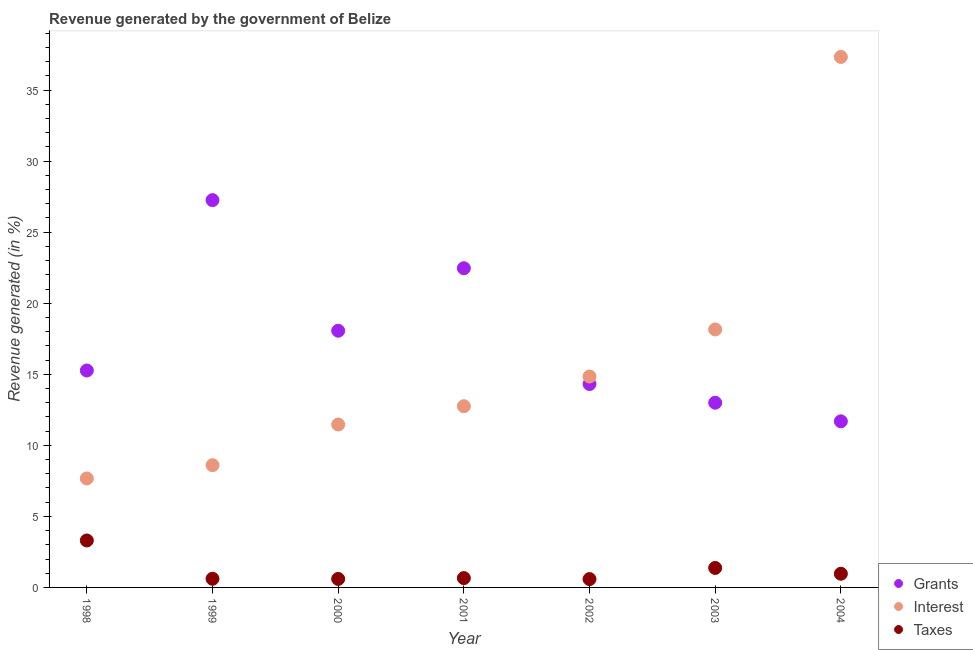What is the percentage of revenue generated by taxes in 2004?
Your answer should be very brief. 0.96. Across all years, what is the maximum percentage of revenue generated by grants?
Offer a terse response. 27.26. Across all years, what is the minimum percentage of revenue generated by grants?
Provide a succinct answer. 11.69. In which year was the percentage of revenue generated by grants minimum?
Ensure brevity in your answer.  2004. What is the total percentage of revenue generated by taxes in the graph?
Offer a very short reply. 8.09. What is the difference between the percentage of revenue generated by taxes in 1999 and that in 2001?
Provide a succinct answer. -0.05. What is the difference between the percentage of revenue generated by interest in 2000 and the percentage of revenue generated by grants in 2004?
Ensure brevity in your answer.  -0.22. What is the average percentage of revenue generated by interest per year?
Keep it short and to the point. 15.83. In the year 1998, what is the difference between the percentage of revenue generated by grants and percentage of revenue generated by interest?
Provide a short and direct response. 7.6. In how many years, is the percentage of revenue generated by taxes greater than 27 %?
Offer a very short reply. 0. What is the ratio of the percentage of revenue generated by interest in 1998 to that in 2003?
Offer a very short reply. 0.42. Is the percentage of revenue generated by grants in 1999 less than that in 2000?
Your answer should be very brief. No. Is the difference between the percentage of revenue generated by grants in 1998 and 2003 greater than the difference between the percentage of revenue generated by taxes in 1998 and 2003?
Keep it short and to the point. Yes. What is the difference between the highest and the second highest percentage of revenue generated by grants?
Ensure brevity in your answer.  4.79. What is the difference between the highest and the lowest percentage of revenue generated by taxes?
Keep it short and to the point. 2.72. Is the sum of the percentage of revenue generated by interest in 1998 and 2001 greater than the maximum percentage of revenue generated by taxes across all years?
Provide a succinct answer. Yes. Is it the case that in every year, the sum of the percentage of revenue generated by grants and percentage of revenue generated by interest is greater than the percentage of revenue generated by taxes?
Keep it short and to the point. Yes. Does the percentage of revenue generated by grants monotonically increase over the years?
Provide a succinct answer. No. Is the percentage of revenue generated by grants strictly less than the percentage of revenue generated by interest over the years?
Offer a very short reply. No. How many legend labels are there?
Provide a short and direct response. 3. What is the title of the graph?
Keep it short and to the point. Revenue generated by the government of Belize. What is the label or title of the X-axis?
Offer a very short reply. Year. What is the label or title of the Y-axis?
Make the answer very short. Revenue generated (in %). What is the Revenue generated (in %) of Grants in 1998?
Your answer should be very brief. 15.27. What is the Revenue generated (in %) of Interest in 1998?
Keep it short and to the point. 7.67. What is the Revenue generated (in %) of Taxes in 1998?
Your answer should be very brief. 3.3. What is the Revenue generated (in %) of Grants in 1999?
Ensure brevity in your answer.  27.26. What is the Revenue generated (in %) of Interest in 1999?
Your answer should be very brief. 8.6. What is the Revenue generated (in %) in Taxes in 1999?
Offer a very short reply. 0.61. What is the Revenue generated (in %) in Grants in 2000?
Provide a short and direct response. 18.07. What is the Revenue generated (in %) of Interest in 2000?
Provide a short and direct response. 11.47. What is the Revenue generated (in %) in Taxes in 2000?
Ensure brevity in your answer.  0.6. What is the Revenue generated (in %) of Grants in 2001?
Give a very brief answer. 22.46. What is the Revenue generated (in %) of Interest in 2001?
Provide a short and direct response. 12.75. What is the Revenue generated (in %) in Taxes in 2001?
Offer a very short reply. 0.66. What is the Revenue generated (in %) of Grants in 2002?
Offer a terse response. 14.31. What is the Revenue generated (in %) in Interest in 2002?
Give a very brief answer. 14.84. What is the Revenue generated (in %) in Taxes in 2002?
Your response must be concise. 0.59. What is the Revenue generated (in %) in Grants in 2003?
Provide a short and direct response. 13. What is the Revenue generated (in %) of Interest in 2003?
Make the answer very short. 18.15. What is the Revenue generated (in %) in Taxes in 2003?
Give a very brief answer. 1.37. What is the Revenue generated (in %) in Grants in 2004?
Provide a succinct answer. 11.69. What is the Revenue generated (in %) of Interest in 2004?
Make the answer very short. 37.33. What is the Revenue generated (in %) in Taxes in 2004?
Make the answer very short. 0.96. Across all years, what is the maximum Revenue generated (in %) of Grants?
Make the answer very short. 27.26. Across all years, what is the maximum Revenue generated (in %) of Interest?
Offer a very short reply. 37.33. Across all years, what is the maximum Revenue generated (in %) of Taxes?
Your answer should be compact. 3.3. Across all years, what is the minimum Revenue generated (in %) in Grants?
Your response must be concise. 11.69. Across all years, what is the minimum Revenue generated (in %) in Interest?
Provide a short and direct response. 7.67. Across all years, what is the minimum Revenue generated (in %) of Taxes?
Offer a very short reply. 0.59. What is the total Revenue generated (in %) of Grants in the graph?
Your response must be concise. 122.05. What is the total Revenue generated (in %) in Interest in the graph?
Provide a succinct answer. 110.82. What is the total Revenue generated (in %) of Taxes in the graph?
Offer a very short reply. 8.09. What is the difference between the Revenue generated (in %) of Grants in 1998 and that in 1999?
Ensure brevity in your answer.  -11.99. What is the difference between the Revenue generated (in %) in Interest in 1998 and that in 1999?
Make the answer very short. -0.94. What is the difference between the Revenue generated (in %) of Taxes in 1998 and that in 1999?
Your answer should be compact. 2.69. What is the difference between the Revenue generated (in %) in Grants in 1998 and that in 2000?
Your answer should be compact. -2.8. What is the difference between the Revenue generated (in %) of Interest in 1998 and that in 2000?
Make the answer very short. -3.8. What is the difference between the Revenue generated (in %) in Taxes in 1998 and that in 2000?
Ensure brevity in your answer.  2.71. What is the difference between the Revenue generated (in %) of Grants in 1998 and that in 2001?
Offer a terse response. -7.2. What is the difference between the Revenue generated (in %) in Interest in 1998 and that in 2001?
Give a very brief answer. -5.08. What is the difference between the Revenue generated (in %) in Taxes in 1998 and that in 2001?
Your answer should be compact. 2.65. What is the difference between the Revenue generated (in %) in Grants in 1998 and that in 2002?
Give a very brief answer. 0.95. What is the difference between the Revenue generated (in %) of Interest in 1998 and that in 2002?
Provide a succinct answer. -7.17. What is the difference between the Revenue generated (in %) in Taxes in 1998 and that in 2002?
Give a very brief answer. 2.72. What is the difference between the Revenue generated (in %) of Grants in 1998 and that in 2003?
Provide a short and direct response. 2.27. What is the difference between the Revenue generated (in %) of Interest in 1998 and that in 2003?
Give a very brief answer. -10.49. What is the difference between the Revenue generated (in %) in Taxes in 1998 and that in 2003?
Provide a short and direct response. 1.93. What is the difference between the Revenue generated (in %) of Grants in 1998 and that in 2004?
Ensure brevity in your answer.  3.58. What is the difference between the Revenue generated (in %) of Interest in 1998 and that in 2004?
Ensure brevity in your answer.  -29.66. What is the difference between the Revenue generated (in %) in Taxes in 1998 and that in 2004?
Give a very brief answer. 2.34. What is the difference between the Revenue generated (in %) of Grants in 1999 and that in 2000?
Provide a short and direct response. 9.19. What is the difference between the Revenue generated (in %) of Interest in 1999 and that in 2000?
Provide a short and direct response. -2.86. What is the difference between the Revenue generated (in %) of Taxes in 1999 and that in 2000?
Your answer should be compact. 0.01. What is the difference between the Revenue generated (in %) in Grants in 1999 and that in 2001?
Provide a short and direct response. 4.79. What is the difference between the Revenue generated (in %) of Interest in 1999 and that in 2001?
Offer a very short reply. -4.15. What is the difference between the Revenue generated (in %) in Taxes in 1999 and that in 2001?
Ensure brevity in your answer.  -0.05. What is the difference between the Revenue generated (in %) in Grants in 1999 and that in 2002?
Give a very brief answer. 12.94. What is the difference between the Revenue generated (in %) of Interest in 1999 and that in 2002?
Your answer should be very brief. -6.24. What is the difference between the Revenue generated (in %) in Taxes in 1999 and that in 2002?
Provide a succinct answer. 0.02. What is the difference between the Revenue generated (in %) in Grants in 1999 and that in 2003?
Your answer should be very brief. 14.26. What is the difference between the Revenue generated (in %) in Interest in 1999 and that in 2003?
Your answer should be compact. -9.55. What is the difference between the Revenue generated (in %) in Taxes in 1999 and that in 2003?
Your answer should be very brief. -0.76. What is the difference between the Revenue generated (in %) of Grants in 1999 and that in 2004?
Provide a succinct answer. 15.57. What is the difference between the Revenue generated (in %) of Interest in 1999 and that in 2004?
Provide a succinct answer. -28.73. What is the difference between the Revenue generated (in %) of Taxes in 1999 and that in 2004?
Offer a terse response. -0.35. What is the difference between the Revenue generated (in %) in Grants in 2000 and that in 2001?
Your answer should be compact. -4.4. What is the difference between the Revenue generated (in %) of Interest in 2000 and that in 2001?
Give a very brief answer. -1.29. What is the difference between the Revenue generated (in %) of Taxes in 2000 and that in 2001?
Ensure brevity in your answer.  -0.06. What is the difference between the Revenue generated (in %) of Grants in 2000 and that in 2002?
Keep it short and to the point. 3.75. What is the difference between the Revenue generated (in %) in Interest in 2000 and that in 2002?
Your response must be concise. -3.38. What is the difference between the Revenue generated (in %) of Taxes in 2000 and that in 2002?
Give a very brief answer. 0.01. What is the difference between the Revenue generated (in %) of Grants in 2000 and that in 2003?
Your answer should be compact. 5.07. What is the difference between the Revenue generated (in %) in Interest in 2000 and that in 2003?
Keep it short and to the point. -6.69. What is the difference between the Revenue generated (in %) of Taxes in 2000 and that in 2003?
Offer a very short reply. -0.77. What is the difference between the Revenue generated (in %) of Grants in 2000 and that in 2004?
Give a very brief answer. 6.38. What is the difference between the Revenue generated (in %) of Interest in 2000 and that in 2004?
Your answer should be very brief. -25.87. What is the difference between the Revenue generated (in %) of Taxes in 2000 and that in 2004?
Give a very brief answer. -0.37. What is the difference between the Revenue generated (in %) in Grants in 2001 and that in 2002?
Give a very brief answer. 8.15. What is the difference between the Revenue generated (in %) in Interest in 2001 and that in 2002?
Give a very brief answer. -2.09. What is the difference between the Revenue generated (in %) in Taxes in 2001 and that in 2002?
Your answer should be very brief. 0.07. What is the difference between the Revenue generated (in %) in Grants in 2001 and that in 2003?
Offer a terse response. 9.46. What is the difference between the Revenue generated (in %) of Interest in 2001 and that in 2003?
Your response must be concise. -5.4. What is the difference between the Revenue generated (in %) of Taxes in 2001 and that in 2003?
Provide a succinct answer. -0.71. What is the difference between the Revenue generated (in %) in Grants in 2001 and that in 2004?
Ensure brevity in your answer.  10.77. What is the difference between the Revenue generated (in %) in Interest in 2001 and that in 2004?
Your response must be concise. -24.58. What is the difference between the Revenue generated (in %) of Taxes in 2001 and that in 2004?
Make the answer very short. -0.31. What is the difference between the Revenue generated (in %) of Grants in 2002 and that in 2003?
Offer a terse response. 1.32. What is the difference between the Revenue generated (in %) of Interest in 2002 and that in 2003?
Make the answer very short. -3.31. What is the difference between the Revenue generated (in %) in Taxes in 2002 and that in 2003?
Your answer should be compact. -0.78. What is the difference between the Revenue generated (in %) of Grants in 2002 and that in 2004?
Your response must be concise. 2.62. What is the difference between the Revenue generated (in %) in Interest in 2002 and that in 2004?
Provide a succinct answer. -22.49. What is the difference between the Revenue generated (in %) in Taxes in 2002 and that in 2004?
Offer a very short reply. -0.38. What is the difference between the Revenue generated (in %) in Grants in 2003 and that in 2004?
Your response must be concise. 1.31. What is the difference between the Revenue generated (in %) of Interest in 2003 and that in 2004?
Keep it short and to the point. -19.18. What is the difference between the Revenue generated (in %) of Taxes in 2003 and that in 2004?
Provide a short and direct response. 0.41. What is the difference between the Revenue generated (in %) in Grants in 1998 and the Revenue generated (in %) in Interest in 1999?
Your response must be concise. 6.66. What is the difference between the Revenue generated (in %) in Grants in 1998 and the Revenue generated (in %) in Taxes in 1999?
Offer a terse response. 14.66. What is the difference between the Revenue generated (in %) of Interest in 1998 and the Revenue generated (in %) of Taxes in 1999?
Make the answer very short. 7.06. What is the difference between the Revenue generated (in %) in Grants in 1998 and the Revenue generated (in %) in Interest in 2000?
Offer a terse response. 3.8. What is the difference between the Revenue generated (in %) of Grants in 1998 and the Revenue generated (in %) of Taxes in 2000?
Ensure brevity in your answer.  14.67. What is the difference between the Revenue generated (in %) of Interest in 1998 and the Revenue generated (in %) of Taxes in 2000?
Give a very brief answer. 7.07. What is the difference between the Revenue generated (in %) of Grants in 1998 and the Revenue generated (in %) of Interest in 2001?
Give a very brief answer. 2.51. What is the difference between the Revenue generated (in %) in Grants in 1998 and the Revenue generated (in %) in Taxes in 2001?
Provide a succinct answer. 14.61. What is the difference between the Revenue generated (in %) in Interest in 1998 and the Revenue generated (in %) in Taxes in 2001?
Make the answer very short. 7.01. What is the difference between the Revenue generated (in %) in Grants in 1998 and the Revenue generated (in %) in Interest in 2002?
Keep it short and to the point. 0.42. What is the difference between the Revenue generated (in %) of Grants in 1998 and the Revenue generated (in %) of Taxes in 2002?
Keep it short and to the point. 14.68. What is the difference between the Revenue generated (in %) in Interest in 1998 and the Revenue generated (in %) in Taxes in 2002?
Ensure brevity in your answer.  7.08. What is the difference between the Revenue generated (in %) of Grants in 1998 and the Revenue generated (in %) of Interest in 2003?
Your answer should be very brief. -2.89. What is the difference between the Revenue generated (in %) of Grants in 1998 and the Revenue generated (in %) of Taxes in 2003?
Offer a very short reply. 13.9. What is the difference between the Revenue generated (in %) of Interest in 1998 and the Revenue generated (in %) of Taxes in 2003?
Your answer should be very brief. 6.3. What is the difference between the Revenue generated (in %) of Grants in 1998 and the Revenue generated (in %) of Interest in 2004?
Provide a succinct answer. -22.07. What is the difference between the Revenue generated (in %) of Grants in 1998 and the Revenue generated (in %) of Taxes in 2004?
Your answer should be very brief. 14.3. What is the difference between the Revenue generated (in %) of Interest in 1998 and the Revenue generated (in %) of Taxes in 2004?
Provide a succinct answer. 6.7. What is the difference between the Revenue generated (in %) of Grants in 1999 and the Revenue generated (in %) of Interest in 2000?
Your response must be concise. 15.79. What is the difference between the Revenue generated (in %) of Grants in 1999 and the Revenue generated (in %) of Taxes in 2000?
Offer a very short reply. 26.66. What is the difference between the Revenue generated (in %) in Interest in 1999 and the Revenue generated (in %) in Taxes in 2000?
Your response must be concise. 8.01. What is the difference between the Revenue generated (in %) in Grants in 1999 and the Revenue generated (in %) in Interest in 2001?
Make the answer very short. 14.5. What is the difference between the Revenue generated (in %) in Grants in 1999 and the Revenue generated (in %) in Taxes in 2001?
Your answer should be very brief. 26.6. What is the difference between the Revenue generated (in %) in Interest in 1999 and the Revenue generated (in %) in Taxes in 2001?
Keep it short and to the point. 7.95. What is the difference between the Revenue generated (in %) of Grants in 1999 and the Revenue generated (in %) of Interest in 2002?
Offer a very short reply. 12.41. What is the difference between the Revenue generated (in %) in Grants in 1999 and the Revenue generated (in %) in Taxes in 2002?
Your response must be concise. 26.67. What is the difference between the Revenue generated (in %) of Interest in 1999 and the Revenue generated (in %) of Taxes in 2002?
Provide a succinct answer. 8.02. What is the difference between the Revenue generated (in %) in Grants in 1999 and the Revenue generated (in %) in Interest in 2003?
Provide a short and direct response. 9.1. What is the difference between the Revenue generated (in %) in Grants in 1999 and the Revenue generated (in %) in Taxes in 2003?
Your answer should be very brief. 25.88. What is the difference between the Revenue generated (in %) of Interest in 1999 and the Revenue generated (in %) of Taxes in 2003?
Provide a succinct answer. 7.23. What is the difference between the Revenue generated (in %) of Grants in 1999 and the Revenue generated (in %) of Interest in 2004?
Your answer should be compact. -10.08. What is the difference between the Revenue generated (in %) in Grants in 1999 and the Revenue generated (in %) in Taxes in 2004?
Offer a terse response. 26.29. What is the difference between the Revenue generated (in %) of Interest in 1999 and the Revenue generated (in %) of Taxes in 2004?
Keep it short and to the point. 7.64. What is the difference between the Revenue generated (in %) of Grants in 2000 and the Revenue generated (in %) of Interest in 2001?
Make the answer very short. 5.31. What is the difference between the Revenue generated (in %) of Grants in 2000 and the Revenue generated (in %) of Taxes in 2001?
Your answer should be compact. 17.41. What is the difference between the Revenue generated (in %) in Interest in 2000 and the Revenue generated (in %) in Taxes in 2001?
Your response must be concise. 10.81. What is the difference between the Revenue generated (in %) in Grants in 2000 and the Revenue generated (in %) in Interest in 2002?
Offer a very short reply. 3.22. What is the difference between the Revenue generated (in %) in Grants in 2000 and the Revenue generated (in %) in Taxes in 2002?
Offer a very short reply. 17.48. What is the difference between the Revenue generated (in %) in Interest in 2000 and the Revenue generated (in %) in Taxes in 2002?
Offer a very short reply. 10.88. What is the difference between the Revenue generated (in %) in Grants in 2000 and the Revenue generated (in %) in Interest in 2003?
Offer a terse response. -0.09. What is the difference between the Revenue generated (in %) in Grants in 2000 and the Revenue generated (in %) in Taxes in 2003?
Keep it short and to the point. 16.69. What is the difference between the Revenue generated (in %) in Interest in 2000 and the Revenue generated (in %) in Taxes in 2003?
Give a very brief answer. 10.09. What is the difference between the Revenue generated (in %) of Grants in 2000 and the Revenue generated (in %) of Interest in 2004?
Provide a succinct answer. -19.27. What is the difference between the Revenue generated (in %) in Grants in 2000 and the Revenue generated (in %) in Taxes in 2004?
Provide a succinct answer. 17.1. What is the difference between the Revenue generated (in %) of Interest in 2000 and the Revenue generated (in %) of Taxes in 2004?
Provide a succinct answer. 10.5. What is the difference between the Revenue generated (in %) of Grants in 2001 and the Revenue generated (in %) of Interest in 2002?
Keep it short and to the point. 7.62. What is the difference between the Revenue generated (in %) of Grants in 2001 and the Revenue generated (in %) of Taxes in 2002?
Provide a succinct answer. 21.88. What is the difference between the Revenue generated (in %) of Interest in 2001 and the Revenue generated (in %) of Taxes in 2002?
Ensure brevity in your answer.  12.16. What is the difference between the Revenue generated (in %) of Grants in 2001 and the Revenue generated (in %) of Interest in 2003?
Make the answer very short. 4.31. What is the difference between the Revenue generated (in %) in Grants in 2001 and the Revenue generated (in %) in Taxes in 2003?
Offer a very short reply. 21.09. What is the difference between the Revenue generated (in %) of Interest in 2001 and the Revenue generated (in %) of Taxes in 2003?
Provide a short and direct response. 11.38. What is the difference between the Revenue generated (in %) in Grants in 2001 and the Revenue generated (in %) in Interest in 2004?
Provide a short and direct response. -14.87. What is the difference between the Revenue generated (in %) of Grants in 2001 and the Revenue generated (in %) of Taxes in 2004?
Ensure brevity in your answer.  21.5. What is the difference between the Revenue generated (in %) in Interest in 2001 and the Revenue generated (in %) in Taxes in 2004?
Give a very brief answer. 11.79. What is the difference between the Revenue generated (in %) of Grants in 2002 and the Revenue generated (in %) of Interest in 2003?
Your answer should be compact. -3.84. What is the difference between the Revenue generated (in %) of Grants in 2002 and the Revenue generated (in %) of Taxes in 2003?
Your answer should be very brief. 12.94. What is the difference between the Revenue generated (in %) of Interest in 2002 and the Revenue generated (in %) of Taxes in 2003?
Keep it short and to the point. 13.47. What is the difference between the Revenue generated (in %) in Grants in 2002 and the Revenue generated (in %) in Interest in 2004?
Provide a succinct answer. -23.02. What is the difference between the Revenue generated (in %) of Grants in 2002 and the Revenue generated (in %) of Taxes in 2004?
Your answer should be very brief. 13.35. What is the difference between the Revenue generated (in %) of Interest in 2002 and the Revenue generated (in %) of Taxes in 2004?
Keep it short and to the point. 13.88. What is the difference between the Revenue generated (in %) in Grants in 2003 and the Revenue generated (in %) in Interest in 2004?
Provide a succinct answer. -24.33. What is the difference between the Revenue generated (in %) of Grants in 2003 and the Revenue generated (in %) of Taxes in 2004?
Provide a succinct answer. 12.04. What is the difference between the Revenue generated (in %) in Interest in 2003 and the Revenue generated (in %) in Taxes in 2004?
Make the answer very short. 17.19. What is the average Revenue generated (in %) in Grants per year?
Your answer should be very brief. 17.44. What is the average Revenue generated (in %) of Interest per year?
Offer a very short reply. 15.83. What is the average Revenue generated (in %) of Taxes per year?
Give a very brief answer. 1.16. In the year 1998, what is the difference between the Revenue generated (in %) of Grants and Revenue generated (in %) of Interest?
Offer a terse response. 7.6. In the year 1998, what is the difference between the Revenue generated (in %) in Grants and Revenue generated (in %) in Taxes?
Your response must be concise. 11.96. In the year 1998, what is the difference between the Revenue generated (in %) of Interest and Revenue generated (in %) of Taxes?
Your response must be concise. 4.36. In the year 1999, what is the difference between the Revenue generated (in %) in Grants and Revenue generated (in %) in Interest?
Your response must be concise. 18.65. In the year 1999, what is the difference between the Revenue generated (in %) in Grants and Revenue generated (in %) in Taxes?
Your response must be concise. 26.65. In the year 1999, what is the difference between the Revenue generated (in %) of Interest and Revenue generated (in %) of Taxes?
Make the answer very short. 7.99. In the year 2000, what is the difference between the Revenue generated (in %) in Grants and Revenue generated (in %) in Interest?
Provide a succinct answer. 6.6. In the year 2000, what is the difference between the Revenue generated (in %) of Grants and Revenue generated (in %) of Taxes?
Provide a succinct answer. 17.47. In the year 2000, what is the difference between the Revenue generated (in %) in Interest and Revenue generated (in %) in Taxes?
Provide a succinct answer. 10.87. In the year 2001, what is the difference between the Revenue generated (in %) in Grants and Revenue generated (in %) in Interest?
Ensure brevity in your answer.  9.71. In the year 2001, what is the difference between the Revenue generated (in %) in Grants and Revenue generated (in %) in Taxes?
Your answer should be very brief. 21.81. In the year 2001, what is the difference between the Revenue generated (in %) of Interest and Revenue generated (in %) of Taxes?
Give a very brief answer. 12.1. In the year 2002, what is the difference between the Revenue generated (in %) in Grants and Revenue generated (in %) in Interest?
Offer a very short reply. -0.53. In the year 2002, what is the difference between the Revenue generated (in %) in Grants and Revenue generated (in %) in Taxes?
Ensure brevity in your answer.  13.73. In the year 2002, what is the difference between the Revenue generated (in %) of Interest and Revenue generated (in %) of Taxes?
Offer a very short reply. 14.25. In the year 2003, what is the difference between the Revenue generated (in %) of Grants and Revenue generated (in %) of Interest?
Provide a succinct answer. -5.16. In the year 2003, what is the difference between the Revenue generated (in %) of Grants and Revenue generated (in %) of Taxes?
Your answer should be very brief. 11.63. In the year 2003, what is the difference between the Revenue generated (in %) of Interest and Revenue generated (in %) of Taxes?
Give a very brief answer. 16.78. In the year 2004, what is the difference between the Revenue generated (in %) in Grants and Revenue generated (in %) in Interest?
Your response must be concise. -25.64. In the year 2004, what is the difference between the Revenue generated (in %) of Grants and Revenue generated (in %) of Taxes?
Give a very brief answer. 10.73. In the year 2004, what is the difference between the Revenue generated (in %) in Interest and Revenue generated (in %) in Taxes?
Ensure brevity in your answer.  36.37. What is the ratio of the Revenue generated (in %) in Grants in 1998 to that in 1999?
Ensure brevity in your answer.  0.56. What is the ratio of the Revenue generated (in %) in Interest in 1998 to that in 1999?
Provide a succinct answer. 0.89. What is the ratio of the Revenue generated (in %) in Taxes in 1998 to that in 1999?
Provide a short and direct response. 5.42. What is the ratio of the Revenue generated (in %) in Grants in 1998 to that in 2000?
Ensure brevity in your answer.  0.85. What is the ratio of the Revenue generated (in %) of Interest in 1998 to that in 2000?
Keep it short and to the point. 0.67. What is the ratio of the Revenue generated (in %) in Taxes in 1998 to that in 2000?
Provide a succinct answer. 5.53. What is the ratio of the Revenue generated (in %) in Grants in 1998 to that in 2001?
Provide a short and direct response. 0.68. What is the ratio of the Revenue generated (in %) in Interest in 1998 to that in 2001?
Keep it short and to the point. 0.6. What is the ratio of the Revenue generated (in %) of Taxes in 1998 to that in 2001?
Ensure brevity in your answer.  5.03. What is the ratio of the Revenue generated (in %) in Grants in 1998 to that in 2002?
Offer a very short reply. 1.07. What is the ratio of the Revenue generated (in %) in Interest in 1998 to that in 2002?
Offer a terse response. 0.52. What is the ratio of the Revenue generated (in %) in Taxes in 1998 to that in 2002?
Provide a short and direct response. 5.62. What is the ratio of the Revenue generated (in %) of Grants in 1998 to that in 2003?
Provide a short and direct response. 1.17. What is the ratio of the Revenue generated (in %) in Interest in 1998 to that in 2003?
Your response must be concise. 0.42. What is the ratio of the Revenue generated (in %) in Taxes in 1998 to that in 2003?
Offer a very short reply. 2.41. What is the ratio of the Revenue generated (in %) of Grants in 1998 to that in 2004?
Your response must be concise. 1.31. What is the ratio of the Revenue generated (in %) of Interest in 1998 to that in 2004?
Ensure brevity in your answer.  0.21. What is the ratio of the Revenue generated (in %) in Taxes in 1998 to that in 2004?
Ensure brevity in your answer.  3.43. What is the ratio of the Revenue generated (in %) in Grants in 1999 to that in 2000?
Your answer should be compact. 1.51. What is the ratio of the Revenue generated (in %) of Interest in 1999 to that in 2000?
Keep it short and to the point. 0.75. What is the ratio of the Revenue generated (in %) in Taxes in 1999 to that in 2000?
Your answer should be very brief. 1.02. What is the ratio of the Revenue generated (in %) in Grants in 1999 to that in 2001?
Make the answer very short. 1.21. What is the ratio of the Revenue generated (in %) of Interest in 1999 to that in 2001?
Offer a terse response. 0.67. What is the ratio of the Revenue generated (in %) of Taxes in 1999 to that in 2001?
Make the answer very short. 0.93. What is the ratio of the Revenue generated (in %) in Grants in 1999 to that in 2002?
Your answer should be very brief. 1.9. What is the ratio of the Revenue generated (in %) in Interest in 1999 to that in 2002?
Offer a terse response. 0.58. What is the ratio of the Revenue generated (in %) of Taxes in 1999 to that in 2002?
Provide a short and direct response. 1.04. What is the ratio of the Revenue generated (in %) in Grants in 1999 to that in 2003?
Offer a terse response. 2.1. What is the ratio of the Revenue generated (in %) of Interest in 1999 to that in 2003?
Give a very brief answer. 0.47. What is the ratio of the Revenue generated (in %) in Taxes in 1999 to that in 2003?
Offer a very short reply. 0.44. What is the ratio of the Revenue generated (in %) in Grants in 1999 to that in 2004?
Offer a very short reply. 2.33. What is the ratio of the Revenue generated (in %) in Interest in 1999 to that in 2004?
Provide a succinct answer. 0.23. What is the ratio of the Revenue generated (in %) of Taxes in 1999 to that in 2004?
Provide a short and direct response. 0.63. What is the ratio of the Revenue generated (in %) of Grants in 2000 to that in 2001?
Give a very brief answer. 0.8. What is the ratio of the Revenue generated (in %) of Interest in 2000 to that in 2001?
Ensure brevity in your answer.  0.9. What is the ratio of the Revenue generated (in %) in Taxes in 2000 to that in 2001?
Your answer should be compact. 0.91. What is the ratio of the Revenue generated (in %) in Grants in 2000 to that in 2002?
Give a very brief answer. 1.26. What is the ratio of the Revenue generated (in %) in Interest in 2000 to that in 2002?
Provide a short and direct response. 0.77. What is the ratio of the Revenue generated (in %) of Taxes in 2000 to that in 2002?
Give a very brief answer. 1.02. What is the ratio of the Revenue generated (in %) in Grants in 2000 to that in 2003?
Provide a succinct answer. 1.39. What is the ratio of the Revenue generated (in %) of Interest in 2000 to that in 2003?
Your response must be concise. 0.63. What is the ratio of the Revenue generated (in %) of Taxes in 2000 to that in 2003?
Your answer should be very brief. 0.44. What is the ratio of the Revenue generated (in %) of Grants in 2000 to that in 2004?
Offer a very short reply. 1.55. What is the ratio of the Revenue generated (in %) in Interest in 2000 to that in 2004?
Keep it short and to the point. 0.31. What is the ratio of the Revenue generated (in %) of Taxes in 2000 to that in 2004?
Keep it short and to the point. 0.62. What is the ratio of the Revenue generated (in %) of Grants in 2001 to that in 2002?
Your answer should be very brief. 1.57. What is the ratio of the Revenue generated (in %) in Interest in 2001 to that in 2002?
Offer a terse response. 0.86. What is the ratio of the Revenue generated (in %) of Taxes in 2001 to that in 2002?
Your answer should be very brief. 1.12. What is the ratio of the Revenue generated (in %) in Grants in 2001 to that in 2003?
Provide a succinct answer. 1.73. What is the ratio of the Revenue generated (in %) in Interest in 2001 to that in 2003?
Offer a very short reply. 0.7. What is the ratio of the Revenue generated (in %) of Taxes in 2001 to that in 2003?
Offer a very short reply. 0.48. What is the ratio of the Revenue generated (in %) in Grants in 2001 to that in 2004?
Your response must be concise. 1.92. What is the ratio of the Revenue generated (in %) of Interest in 2001 to that in 2004?
Your answer should be compact. 0.34. What is the ratio of the Revenue generated (in %) in Taxes in 2001 to that in 2004?
Provide a succinct answer. 0.68. What is the ratio of the Revenue generated (in %) in Grants in 2002 to that in 2003?
Your answer should be compact. 1.1. What is the ratio of the Revenue generated (in %) in Interest in 2002 to that in 2003?
Make the answer very short. 0.82. What is the ratio of the Revenue generated (in %) of Taxes in 2002 to that in 2003?
Provide a succinct answer. 0.43. What is the ratio of the Revenue generated (in %) in Grants in 2002 to that in 2004?
Your response must be concise. 1.22. What is the ratio of the Revenue generated (in %) of Interest in 2002 to that in 2004?
Provide a short and direct response. 0.4. What is the ratio of the Revenue generated (in %) of Taxes in 2002 to that in 2004?
Your response must be concise. 0.61. What is the ratio of the Revenue generated (in %) in Grants in 2003 to that in 2004?
Keep it short and to the point. 1.11. What is the ratio of the Revenue generated (in %) in Interest in 2003 to that in 2004?
Offer a very short reply. 0.49. What is the ratio of the Revenue generated (in %) in Taxes in 2003 to that in 2004?
Make the answer very short. 1.42. What is the difference between the highest and the second highest Revenue generated (in %) of Grants?
Your answer should be compact. 4.79. What is the difference between the highest and the second highest Revenue generated (in %) in Interest?
Provide a succinct answer. 19.18. What is the difference between the highest and the second highest Revenue generated (in %) in Taxes?
Provide a succinct answer. 1.93. What is the difference between the highest and the lowest Revenue generated (in %) in Grants?
Offer a very short reply. 15.57. What is the difference between the highest and the lowest Revenue generated (in %) of Interest?
Ensure brevity in your answer.  29.66. What is the difference between the highest and the lowest Revenue generated (in %) of Taxes?
Keep it short and to the point. 2.72. 